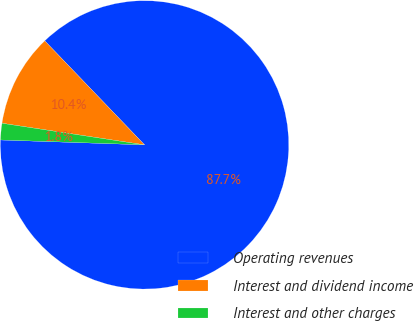Convert chart. <chart><loc_0><loc_0><loc_500><loc_500><pie_chart><fcel>Operating revenues<fcel>Interest and dividend income<fcel>Interest and other charges<nl><fcel>87.72%<fcel>10.44%<fcel>1.85%<nl></chart> 